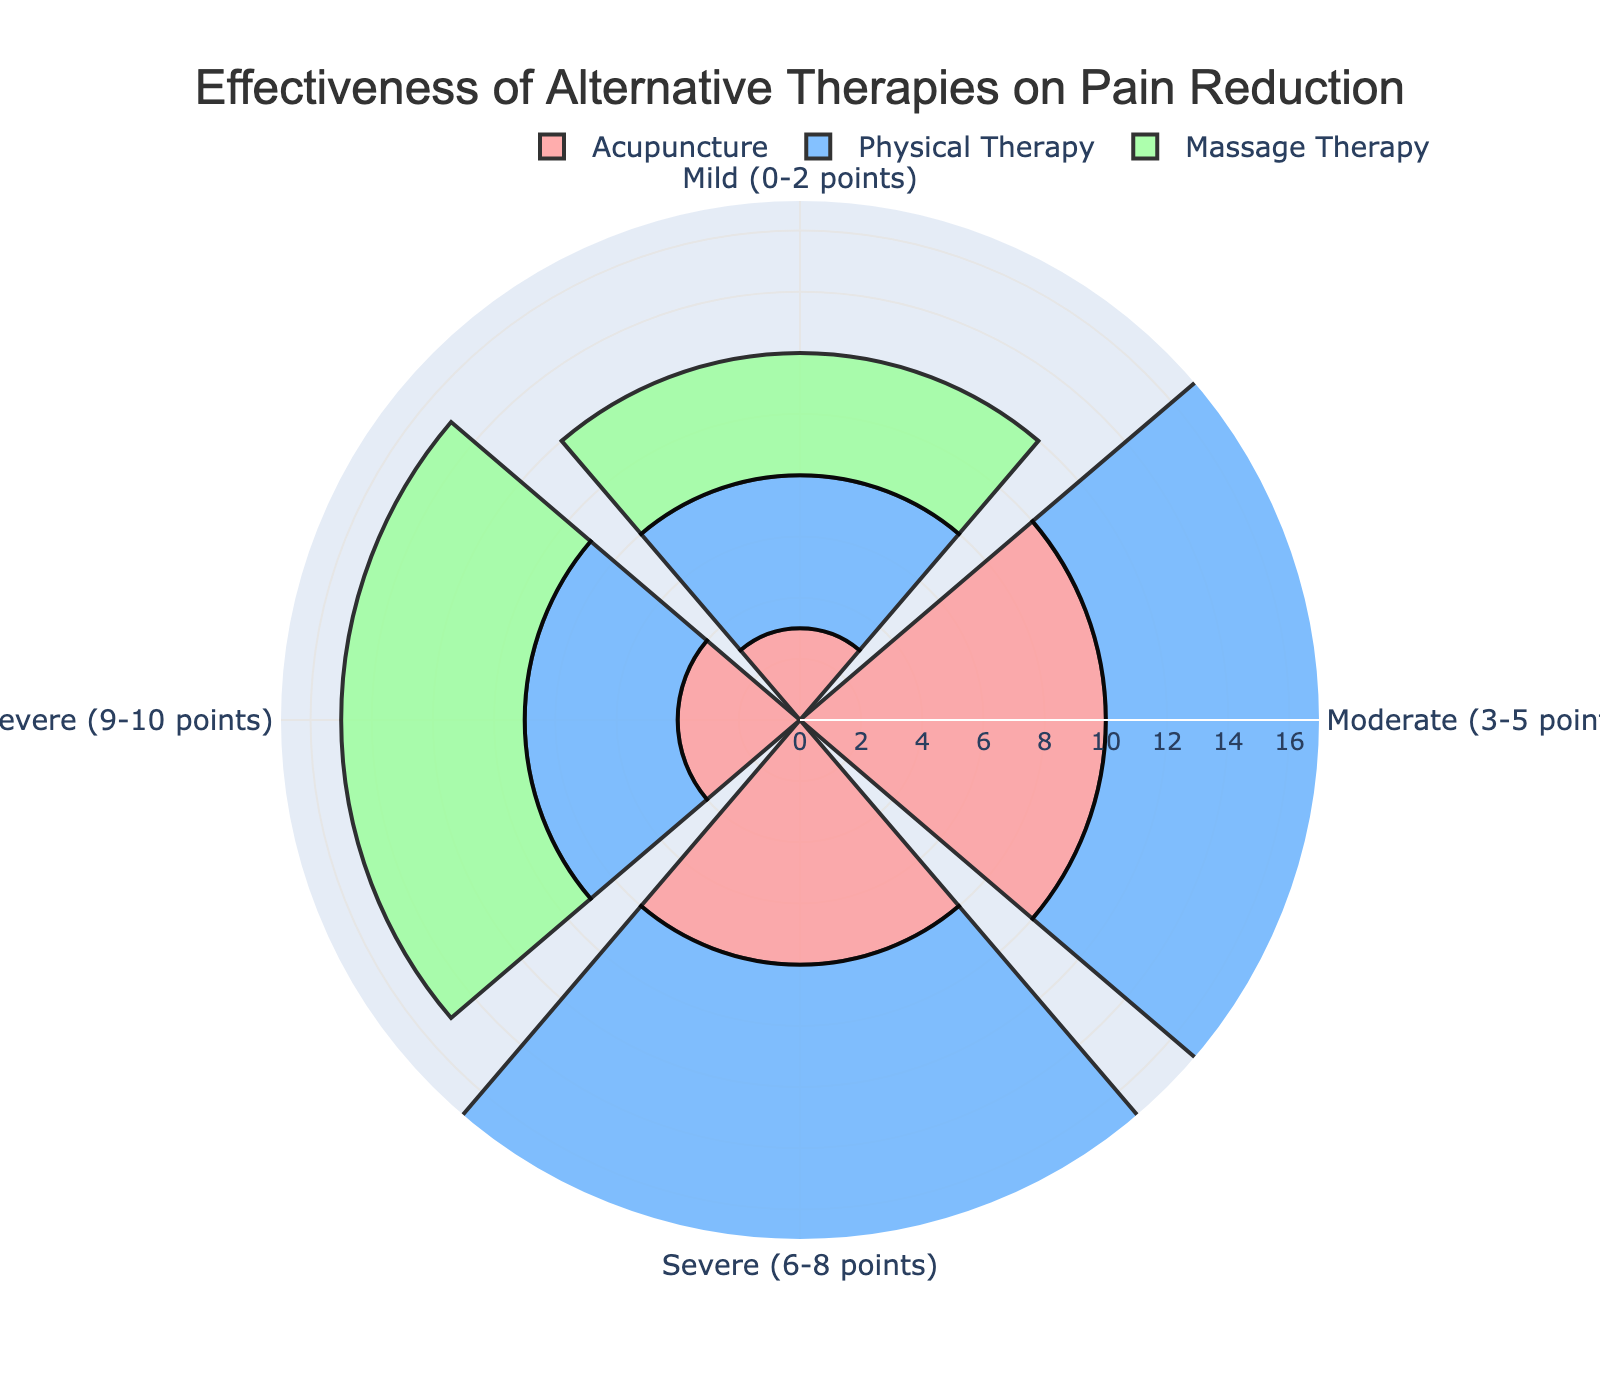What is the title of the plot? The title of the plot is displayed at the top center in larger font. It reads "Effectiveness of Alternative Therapies on Pain Reduction."
Answer: Effectiveness of Alternative Therapies on Pain Reduction Which pain reduction category shows the highest effectiveness for Physical Therapy? By examining the bars corresponding to Physical Therapy across the pain reduction categories (Mild, Moderate, Severe, Very Severe), the longest bar is in the 'Moderate (3-5 points)' category.
Answer: Moderate (3-5 points) Among the three therapies, which achieves the highest pain reduction in the 'Very Severe (9-10 points)' category? By looking at the bars within the 'Very Severe (9-10 points)' category, the highest bar is for Massage Therapy.
Answer: Massage Therapy What is the total effectiveness score for Acupuncture across all pain reduction categories? Adding the values for Acupuncture in each category: Mild (3) + Moderate (10) + Severe (8) + Very Severe (4) = 25.
Answer: 25 How does the effectiveness of Massage Therapy in the 'Moderate (3-5 points)' category compare to Acupuncture in the same category? In the 'Moderate (3-5 points)' category, Massage Therapy has a score of 12 while Acupuncture has a score of 10, therefore, Massage Therapy is higher by 2.
Answer: Massage Therapy is higher by 2 Which therapy has the least effectiveness in the 'Very Severe (9-10 points)' category? Comparing the bars for the 'Very Severe (9-10 points)' category, Acupuncture has the shortest bar indicating the least effectiveness.
Answer: Acupuncture What is the average effectiveness score for Physical Therapy across all pain reduction categories? Adding the effectiveness scores for Physical Therapy: Mild (5) + Moderate (15) + Severe (10) + Very Severe (5). The total is 35. Dividing by the number of categories (4) gives an average of 35/4 = 8.75.
Answer: 8.75 Is there any pain reduction category where all therapies have the same effectiveness score? By examining the length of bars in each category, there isn't any category where all three therapies have bars of equal length.
Answer: No What is the combined effectiveness score for all three therapies in the 'Severe (6-8 points)' category? Summing the scores in the 'Severe (6-8 points)' category: Acupuncture (8) + Physical Therapy (10) + Massage Therapy (9) = 27.
Answer: 27 Which therapy shows the greatest range of effectiveness scores across the four categories? Calculating the range (max - min) for each therapy:
- Acupuncture: max (10, Moderate) - min (3, Mild) = 7
- Physical Therapy: max (15, Moderate) - min (5, Mild) = 10
- Massage Therapy: max (12, Moderate) - min (4, Mild) = 8
Physical Therapy shows the greatest range of 10.
Answer: Physical Therapy 